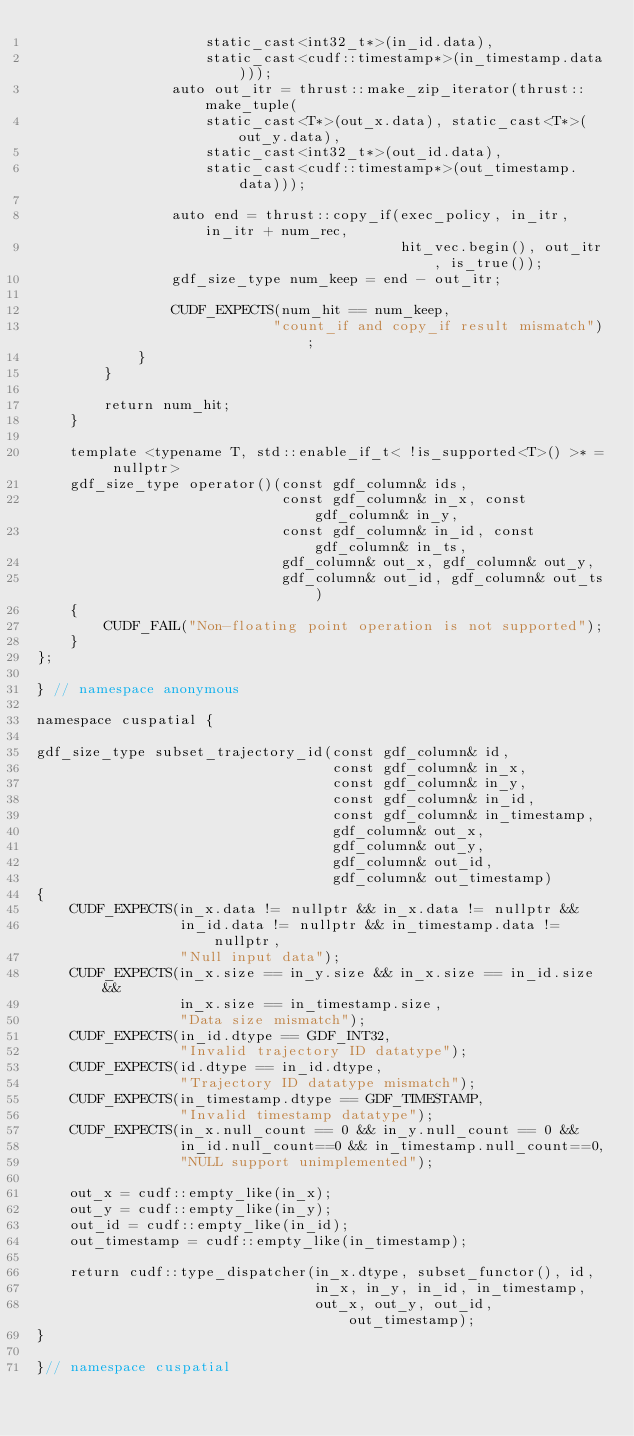Convert code to text. <code><loc_0><loc_0><loc_500><loc_500><_Cuda_>                    static_cast<int32_t*>(in_id.data),
                    static_cast<cudf::timestamp*>(in_timestamp.data)));
                auto out_itr = thrust::make_zip_iterator(thrust::make_tuple(
                    static_cast<T*>(out_x.data), static_cast<T*>(out_y.data),
                    static_cast<int32_t*>(out_id.data),
                    static_cast<cudf::timestamp*>(out_timestamp.data)));

                auto end = thrust::copy_if(exec_policy, in_itr, in_itr + num_rec,
                                           hit_vec.begin(), out_itr, is_true());
                gdf_size_type num_keep = end - out_itr;

                CUDF_EXPECTS(num_hit == num_keep,
                            "count_if and copy_if result mismatch");
            }
        }

        return num_hit;
    }

    template <typename T, std::enable_if_t< !is_supported<T>() >* = nullptr>
    gdf_size_type operator()(const gdf_column& ids,
                             const gdf_column& in_x, const gdf_column& in_y,
                             const gdf_column& in_id, const gdf_column& in_ts,
                             gdf_column& out_x, gdf_column& out_y,
                             gdf_column& out_id, gdf_column& out_ts)
    {
        CUDF_FAIL("Non-floating point operation is not supported");
    }
};

} // namespace anonymous

namespace cuspatial {

gdf_size_type subset_trajectory_id(const gdf_column& id,
                                   const gdf_column& in_x,
                                   const gdf_column& in_y,
                                   const gdf_column& in_id,
                                   const gdf_column& in_timestamp,
                                   gdf_column& out_x,
                                   gdf_column& out_y,
                                   gdf_column& out_id,
                                   gdf_column& out_timestamp)
{
    CUDF_EXPECTS(in_x.data != nullptr && in_x.data != nullptr &&
                 in_id.data != nullptr && in_timestamp.data != nullptr,
                 "Null input data");
    CUDF_EXPECTS(in_x.size == in_y.size && in_x.size == in_id.size &&
                 in_x.size == in_timestamp.size,
                 "Data size mismatch");
    CUDF_EXPECTS(in_id.dtype == GDF_INT32,
                 "Invalid trajectory ID datatype");
    CUDF_EXPECTS(id.dtype == in_id.dtype,
                 "Trajectory ID datatype mismatch");
    CUDF_EXPECTS(in_timestamp.dtype == GDF_TIMESTAMP,
                 "Invalid timestamp datatype");
    CUDF_EXPECTS(in_x.null_count == 0 && in_y.null_count == 0 &&
                 in_id.null_count==0 && in_timestamp.null_count==0,
                 "NULL support unimplemented");

    out_x = cudf::empty_like(in_x);
    out_y = cudf::empty_like(in_y);
    out_id = cudf::empty_like(in_id);
    out_timestamp = cudf::empty_like(in_timestamp);

    return cudf::type_dispatcher(in_x.dtype, subset_functor(), id,
                                 in_x, in_y, in_id, in_timestamp,
                                 out_x, out_y, out_id, out_timestamp);
}

}// namespace cuspatial
</code> 